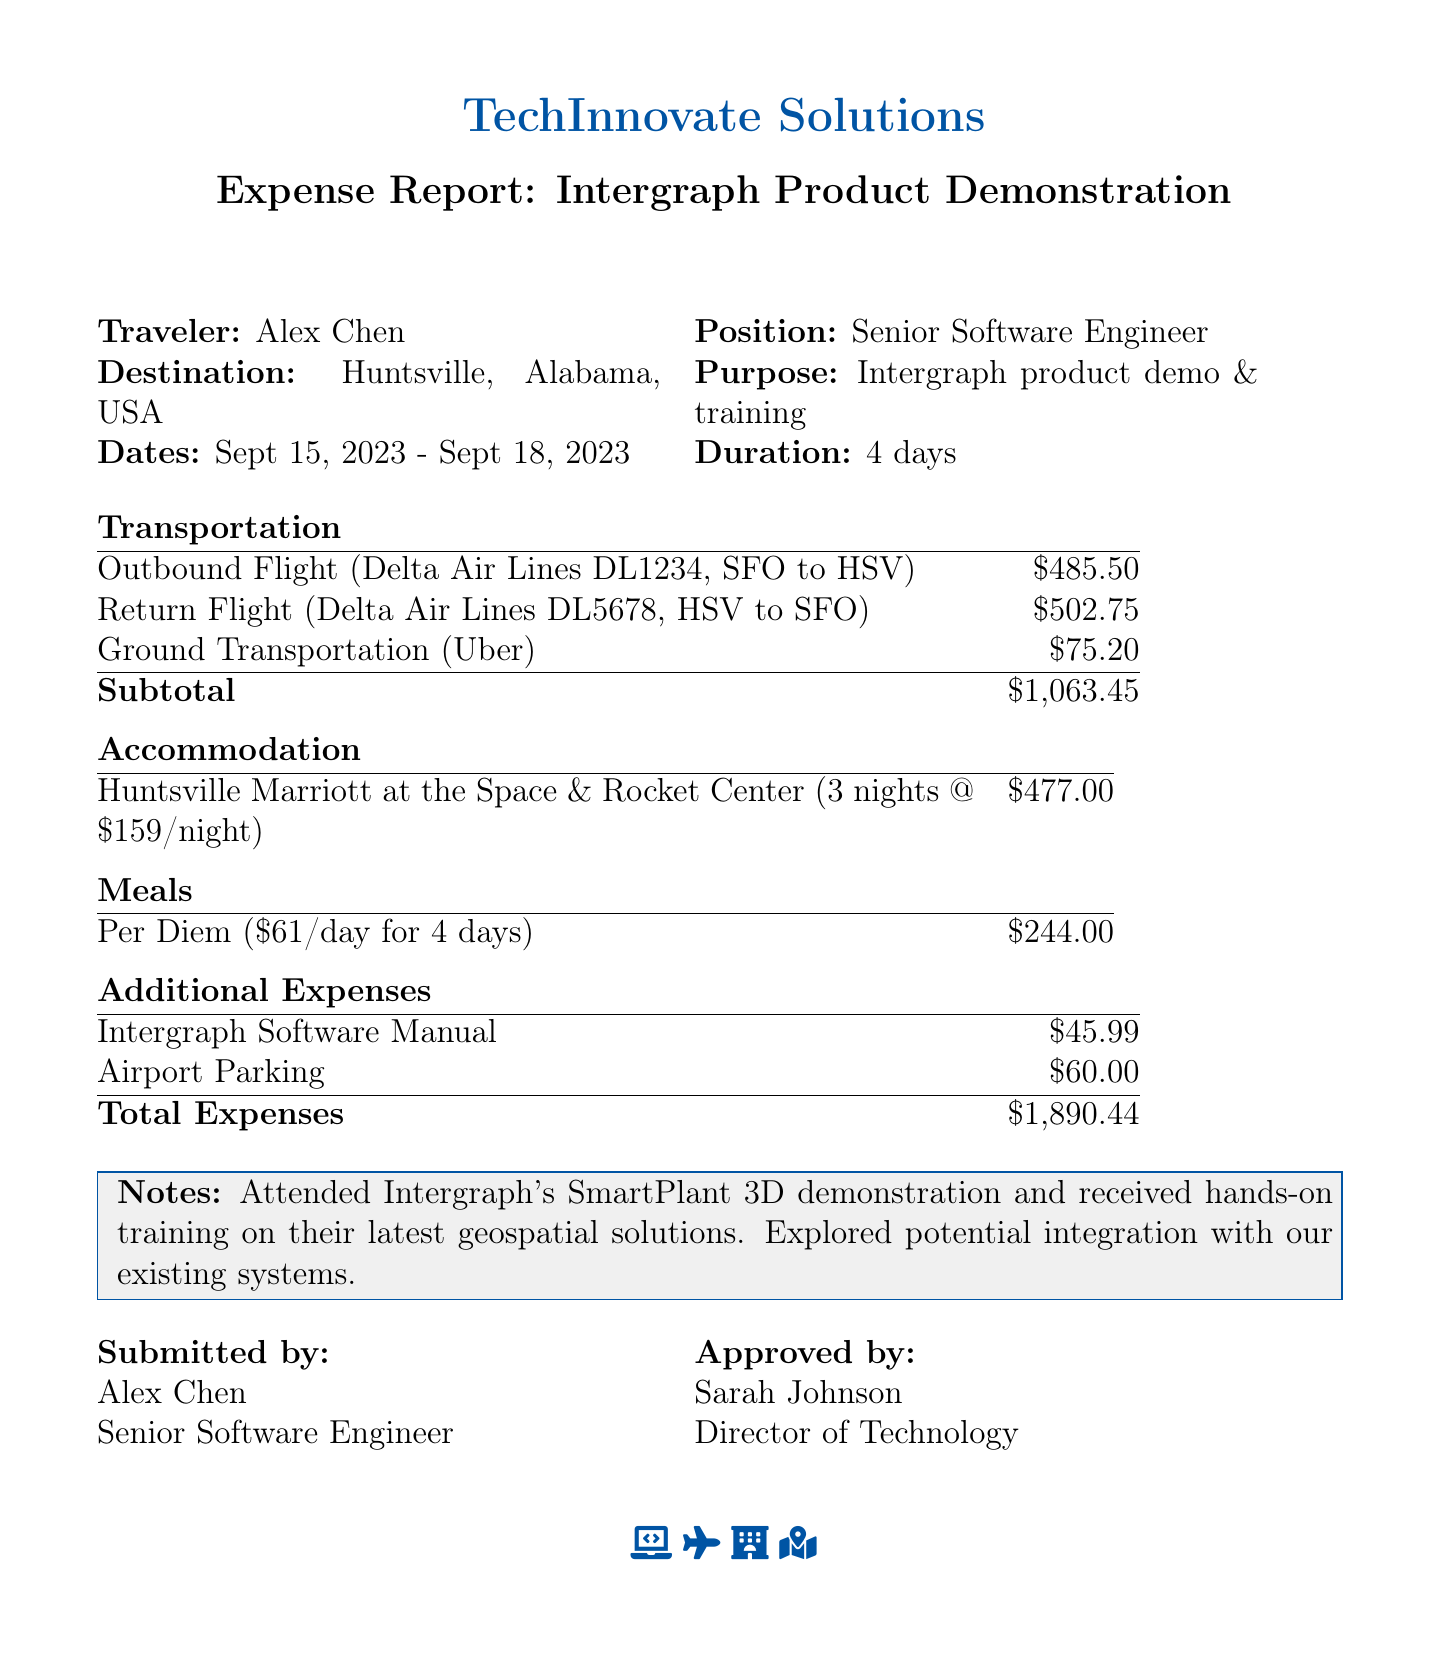What is the total cost for the outbound flight? The total cost for the outbound flight is listed in the transportation section of the document.
Answer: $485.50 Who is the traveler? The name of the traveler is specified at the beginning of the document.
Answer: Alex Chen What is the purpose of the trip? The purpose of the trip is explicitly stated in the document.
Answer: Intergraph product demonstration and training How many nights did the traveler stay at the hotel? The number of nights the traveler stayed is indicated in the accommodation section.
Answer: 3 What is the per diem rate for meals? The per diem rate for meals is provided in the meals section of the document.
Answer: $61.00 What is the total cost for accommodation? The total cost for accommodation is given in the accommodation section of the document.
Answer: $477.00 What transportation method was used for ground travel? The type of ground transportation is mentioned in the transportation section.
Answer: Uber How many days was the trip duration? The trip duration can be calculated from the dates provided in the document.
Answer: 4 days Who approved the expense report? The approver's name is mentioned at the end of the document.
Answer: Sarah Johnson 